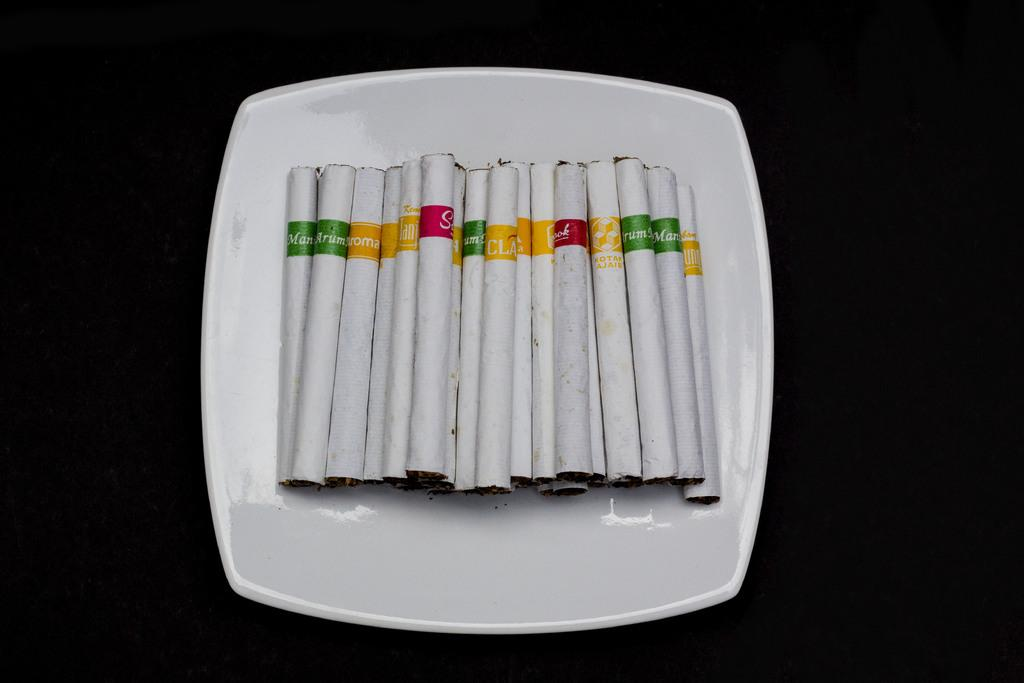What object is present on the plate in the image? The plate has cigarettes on it. What is the color of the background in the image? The background of the image is black. What type of degree does the farmer hold in the image? There is no farmer or degree present in the image. What type of gun is visible in the image? There is no gun present in the image. 